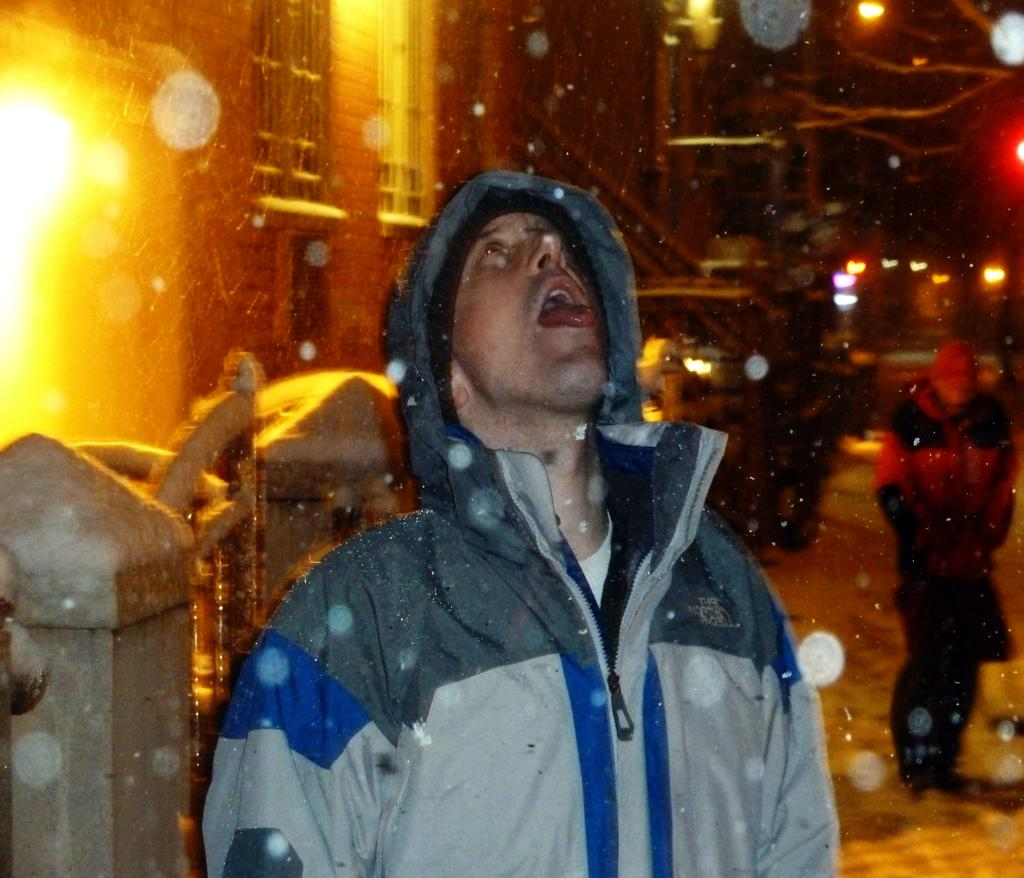Who or what is in the image? There is a person in the image. Where is the person located in relation to other elements in the image? The person is beside a wall. What is the person wearing? The person is wearing clothes. Can you describe the background of the image? The background of the image is blurred. How does the person pull the sun closer in the image? The person does not pull the sun closer in the image, as there is no sun present in the image. 